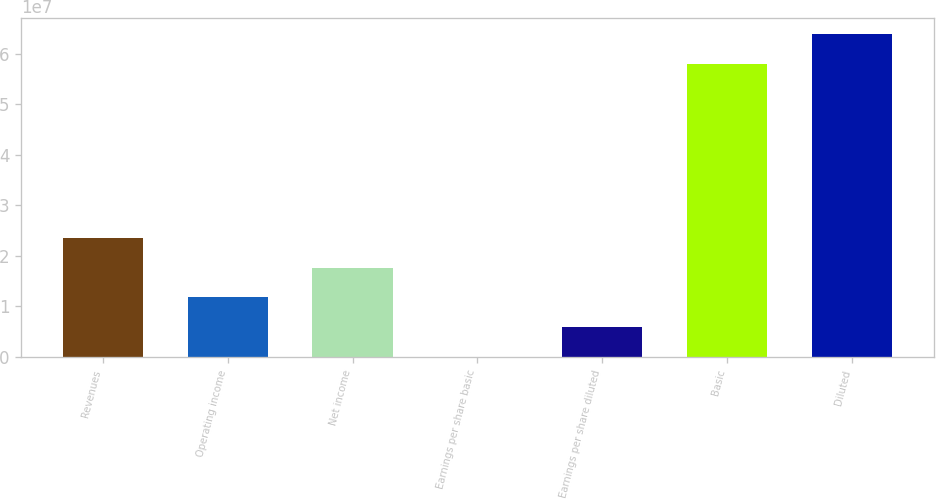Convert chart to OTSL. <chart><loc_0><loc_0><loc_500><loc_500><bar_chart><fcel>Revenues<fcel>Operating income<fcel>Net income<fcel>Earnings per share basic<fcel>Earnings per share diluted<fcel>Basic<fcel>Diluted<nl><fcel>2.35494e+07<fcel>1.17747e+07<fcel>1.76621e+07<fcel>0.24<fcel>5.88735e+06<fcel>5.80032e+07<fcel>6.38906e+07<nl></chart> 